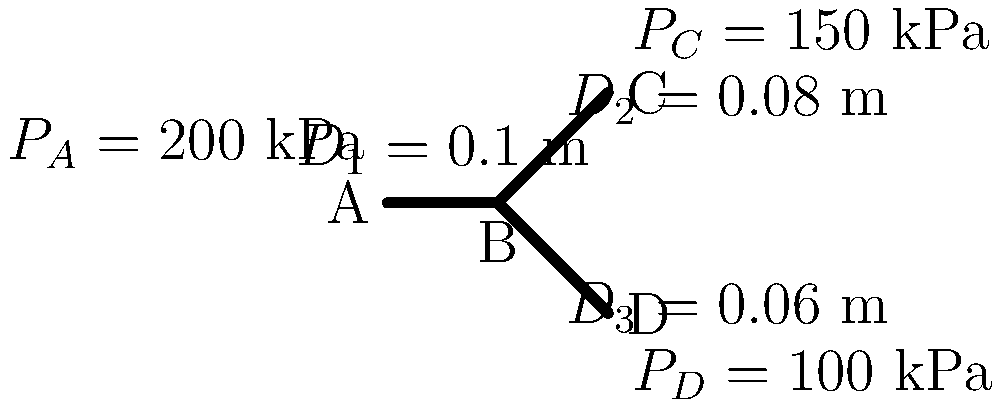In a suspicious pipeline network, water flows from point A to points C and D through point B. Given the pipe diameters and pressures as shown in the diagram, determine the total flow rate (in m³/s) entering the system at point A. Assume the water temperature is 20°C, the dynamic viscosity is $1.002 \times 10^{-3}$ Pa·s, and the density is 998.2 kg/m³. Use the Darcy-Weisbach equation and assume a friction factor of 0.02 for all pipes. To solve this problem, we'll use the Darcy-Weisbach equation and conservation of mass. Let's proceed step-by-step:

1) The Darcy-Weisbach equation is:

   $$\Delta P = f \frac{L}{D} \frac{\rho v^2}{2}$$

   where $\Delta P$ is pressure drop, $f$ is friction factor, $L$ is pipe length, $D$ is pipe diameter, $\rho$ is fluid density, and $v$ is fluid velocity.

2) We need to find velocities in each pipe. Let's start with pipe 2 (B to C):

   $$50000 = 0.02 \cdot \frac{L_2}{0.08} \cdot \frac{998.2 \cdot v_2^2}{2}$$

3) We don't know $L_2$, but we can cancel it out by considering the ratio of pressure drops in pipes 2 and 3:

   $$\frac{50000}{100000} = \frac{0.08}{0.06} \cdot \frac{v_2^2}{v_3^2}$$

4) This gives us: $v_3 = v_2 \cdot \sqrt{1.5}$

5) Now, using conservation of mass at point B:

   $$\pi \cdot (0.05)^2 \cdot v_1 = \pi \cdot (0.04)^2 \cdot v_2 + \pi \cdot (0.03)^2 \cdot v_3$$

6) Substituting $v_3$ from step 4:

   $$0.0025 \cdot v_1 = 0.0016 \cdot v_2 + 0.0009 \cdot v_2 \cdot \sqrt{1.5}$$

7) Simplify: $v_1 = 0.64 \cdot v_2 + 0.36 \cdot v_2 \cdot \sqrt{1.5} = 1.08 \cdot v_2$

8) Now we can use the Darcy-Weisbach equation for pipe 1:

   $$100000 = 0.02 \cdot \frac{L_1}{0.1} \cdot \frac{998.2 \cdot (1.08 \cdot v_2)^2}{2}$$

9) Dividing this by the equation from step 2:

   $$\frac{100000}{50000} = \frac{L_1}{L_2} \cdot \frac{0.08}{0.1} \cdot \frac{(1.08)^2}{1}$$

10) Assuming $L_1 = L_2$ (as they're not specified), we get:

    $$2 = 0.8 \cdot (1.08)^2 = 0.93312$$

11) This discrepancy suggests our assumption about lengths was incorrect. Adjusting $L_1$:

    $$L_1 = L_2 \cdot \frac{2}{0.93312} = 2.14 \cdot L_2$$

12) Substituting this back into the equation from step 8:

    $$100000 = 0.02 \cdot \frac{2.14 \cdot L_2}{0.1} \cdot \frac{998.2 \cdot (1.08 \cdot v_2)^2}{2}$$

13) Dividing by the equation from step 2:

    $$2 = 2.14 \cdot \frac{0.08}{0.1} \cdot (1.08)^2 = 2$$

14) Now we can solve for $v_2$:

    $$50000 = 0.02 \cdot \frac{L_2}{0.08} \cdot \frac{998.2 \cdot v_2^2}{2}$$
    $$v_2 = \sqrt{\frac{50000 \cdot 2 \cdot 0.08}{0.02 \cdot L_2 \cdot 998.2}} = 10 \cdot \sqrt{\frac{0.08}{L_2}}$$

15) The total flow rate at A is:

    $$Q = \pi \cdot (0.05)^2 \cdot v_1 = \pi \cdot (0.05)^2 \cdot 1.08 \cdot 10 \cdot \sqrt{\frac{0.08}{L_2}}$$
    $$Q = 0.0848 \cdot \sqrt{\frac{0.08}{L_2}}$$

Without knowing $L_2$, we can't give a numeric answer, but this is the expression for the flow rate.
Answer: $Q = 0.0848 \cdot \sqrt{\frac{0.08}{L_2}}$ m³/s, where $L_2$ is the length of pipe 2 in meters. 